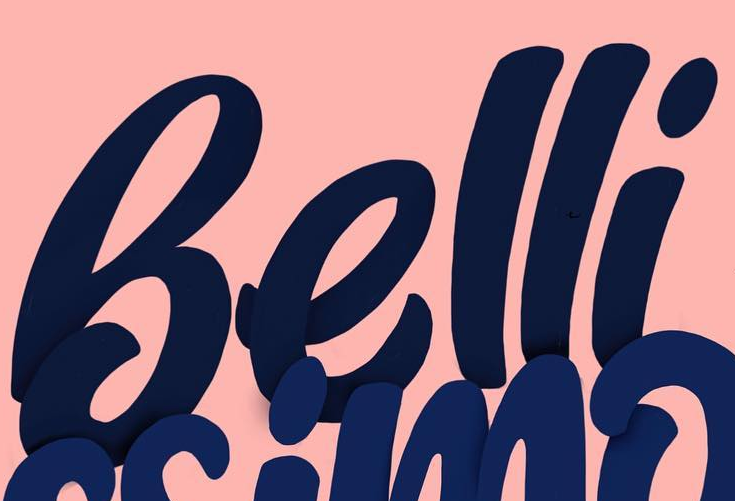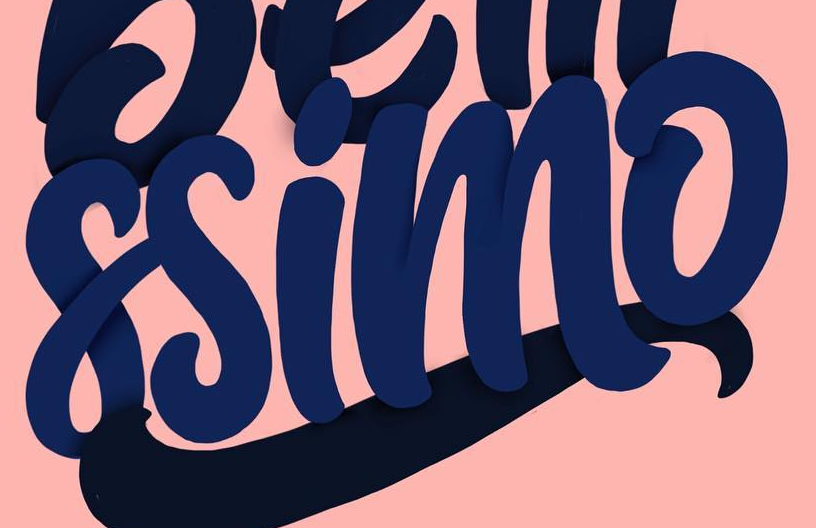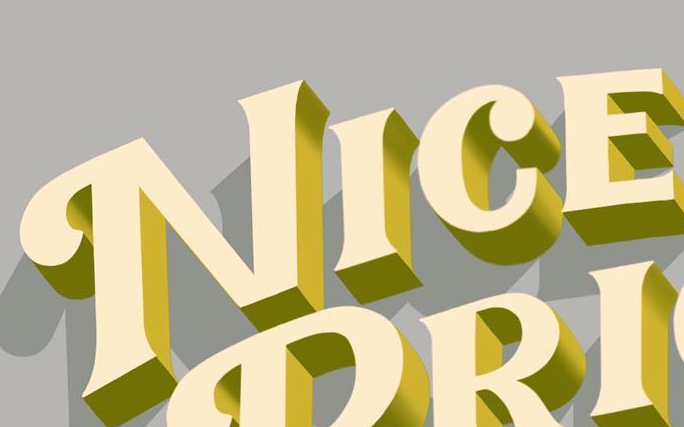Transcribe the words shown in these images in order, separated by a semicolon. Belli; ssimo; NICE 